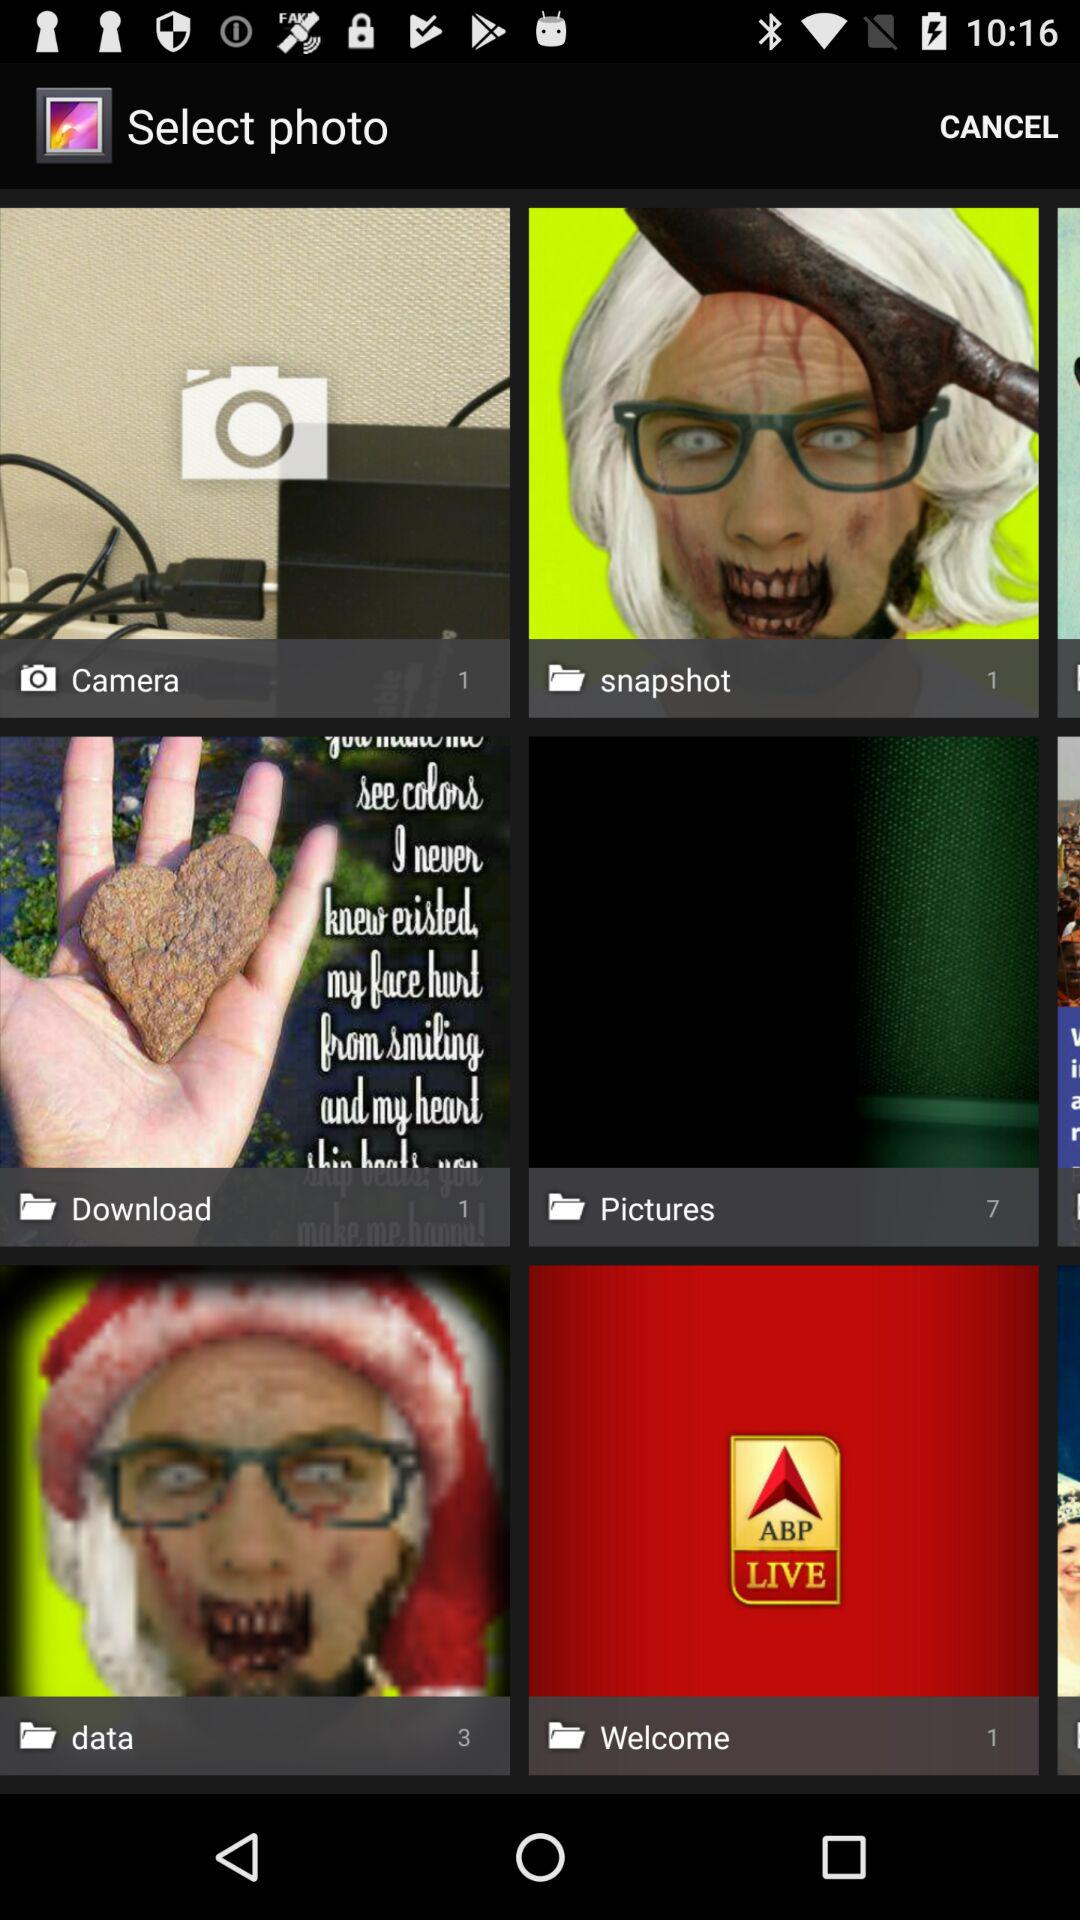What is the number of pictures in the welcome folder? The number of pictures is 1. 